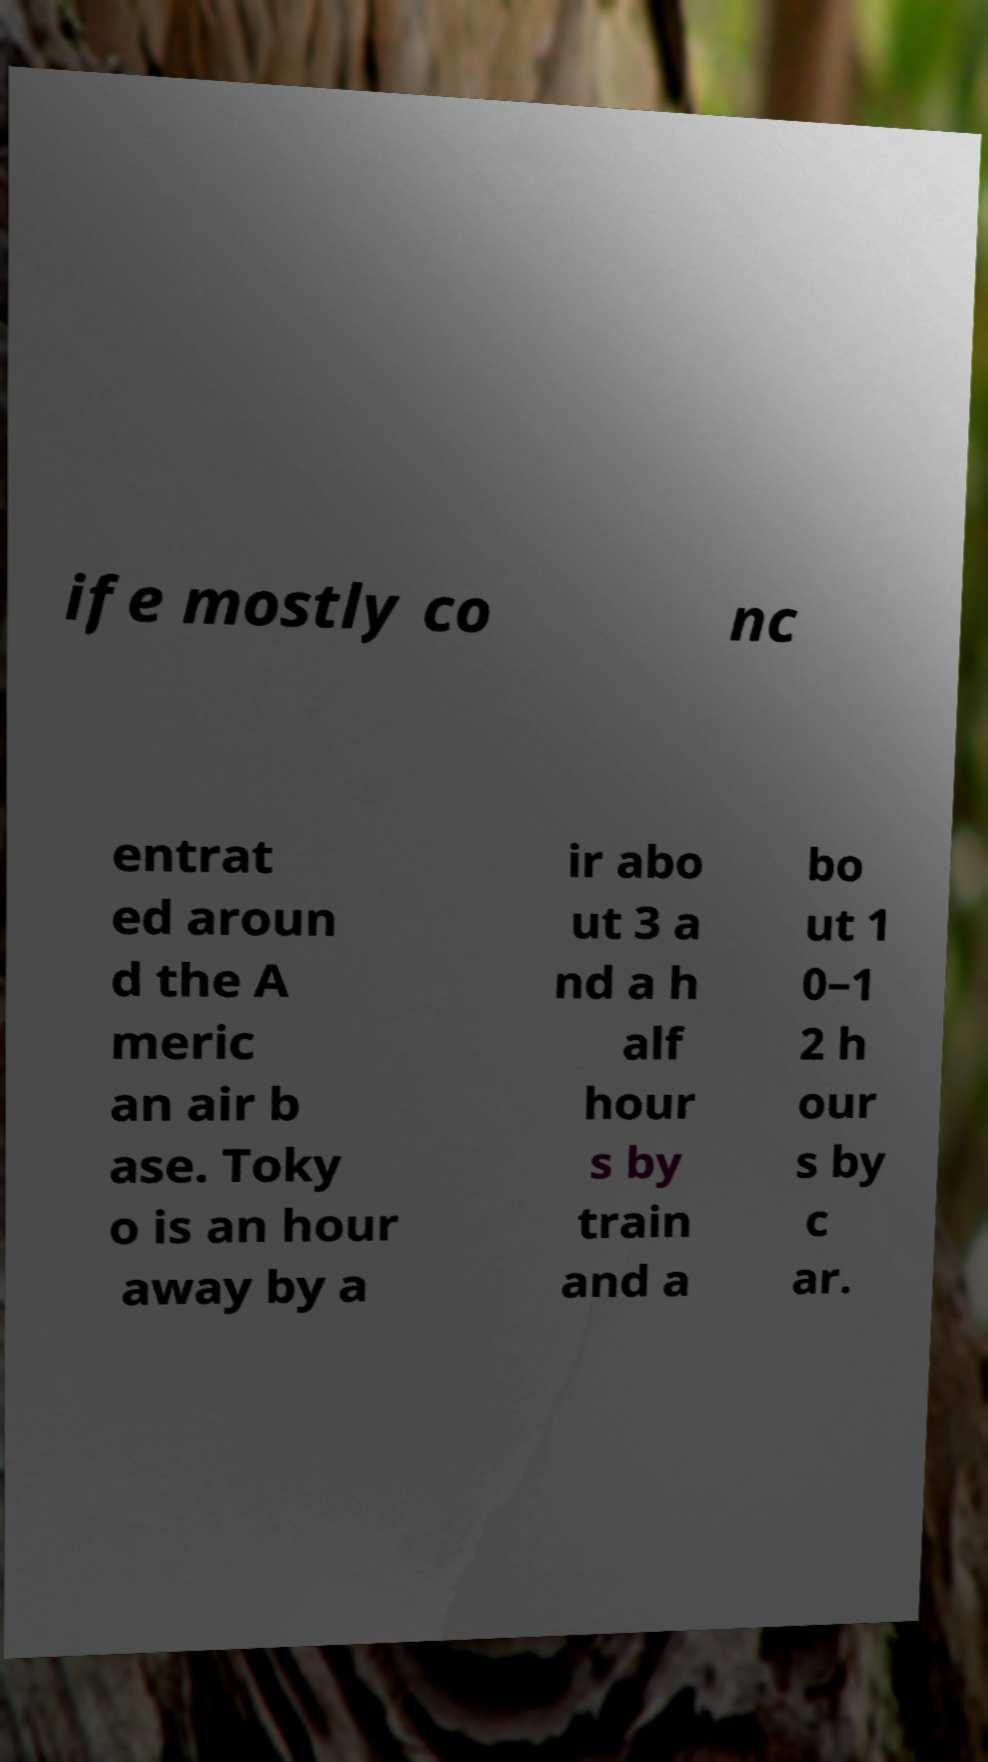For documentation purposes, I need the text within this image transcribed. Could you provide that? ife mostly co nc entrat ed aroun d the A meric an air b ase. Toky o is an hour away by a ir abo ut 3 a nd a h alf hour s by train and a bo ut 1 0–1 2 h our s by c ar. 